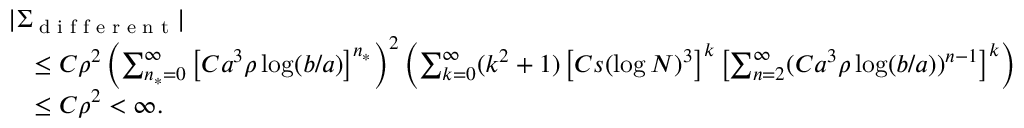<formula> <loc_0><loc_0><loc_500><loc_500>\begin{array} { r l } & { | \Sigma _ { d i f f e r e n t } | } \\ & { \quad \leq C \rho ^ { 2 } \left ( \sum _ { n _ { * } = 0 } ^ { \infty } \left [ C a ^ { 3 } \rho \log ( b / a ) \right ] ^ { n _ { * } } \right ) ^ { 2 } \left ( \sum _ { k = 0 } ^ { \infty } ( k ^ { 2 } + 1 ) \left [ C s ( \log N ) ^ { 3 } \right ] ^ { k } \left [ \sum _ { n = 2 } ^ { \infty } ( C a ^ { 3 } \rho \log ( b / a ) ) ^ { n - 1 } \right ] ^ { k } \right ) } \\ & { \quad \leq C \rho ^ { 2 } < \infty . } \end{array}</formula> 